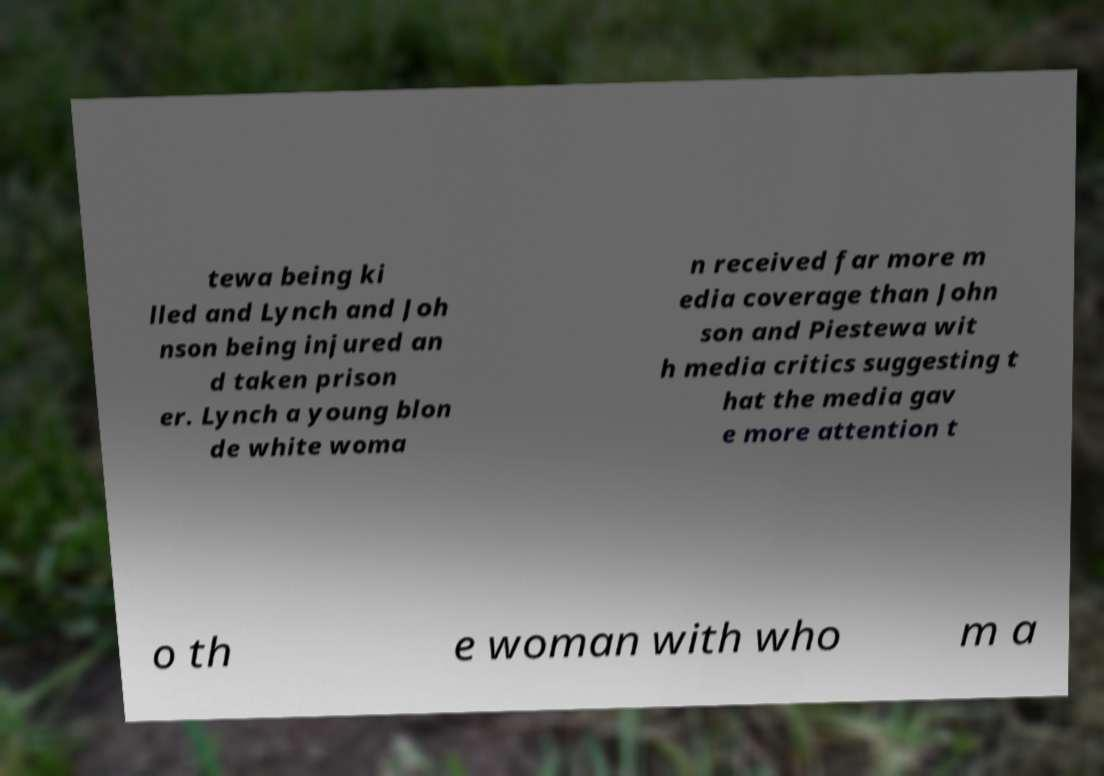Please read and relay the text visible in this image. What does it say? tewa being ki lled and Lynch and Joh nson being injured an d taken prison er. Lynch a young blon de white woma n received far more m edia coverage than John son and Piestewa wit h media critics suggesting t hat the media gav e more attention t o th e woman with who m a 